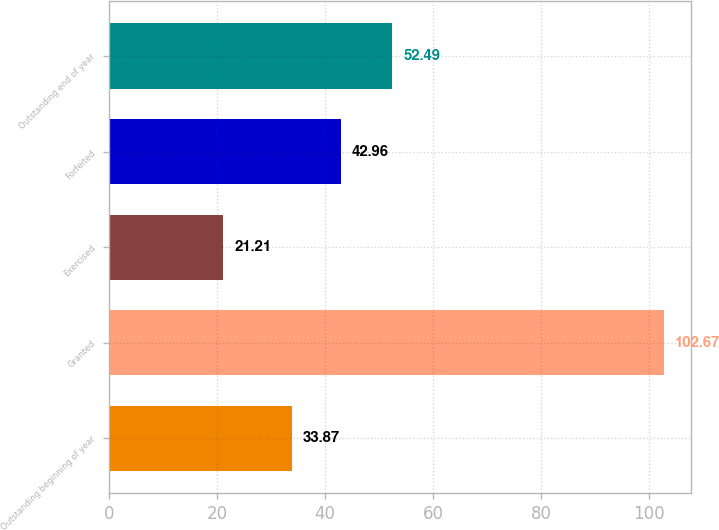Convert chart. <chart><loc_0><loc_0><loc_500><loc_500><bar_chart><fcel>Outstanding beginning of year<fcel>Granted<fcel>Exercised<fcel>Forfeited<fcel>Outstanding end of year<nl><fcel>33.87<fcel>102.67<fcel>21.21<fcel>42.96<fcel>52.49<nl></chart> 